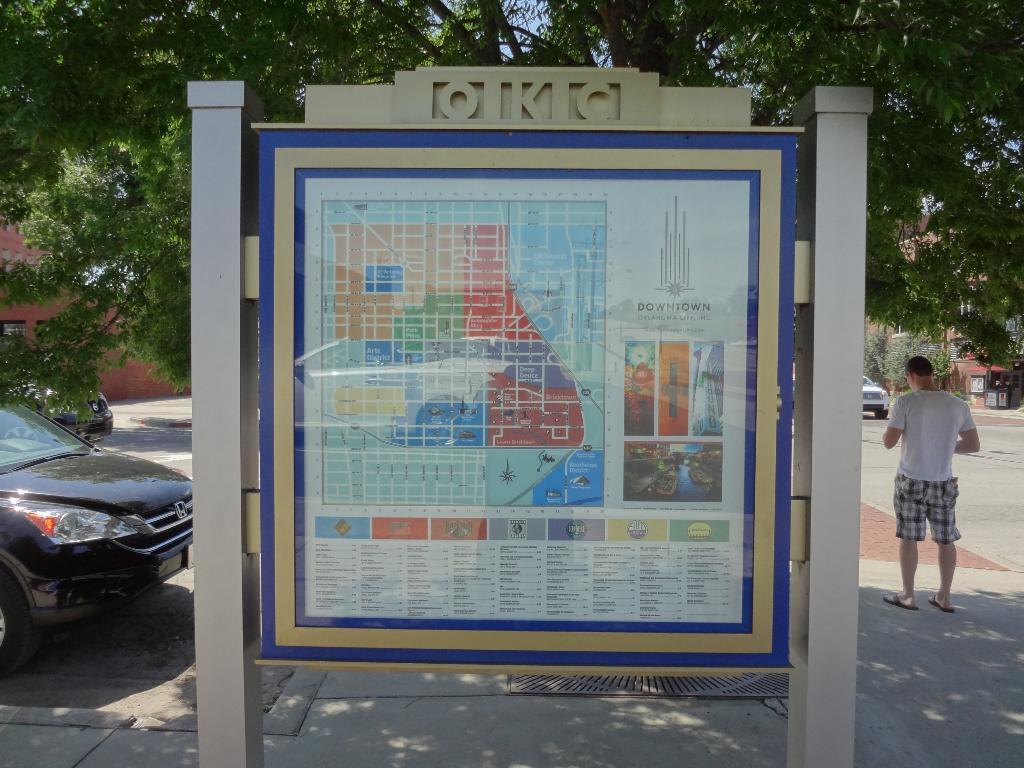Describe this image in one or two sentences. In this image there is a board in between the two poles. In the board there is a map. In the background there are trees. On the left side there is a car on the floor. On the right side there is a person standing on the floor. In the background there is a building. On the right side there is a car on the road. 